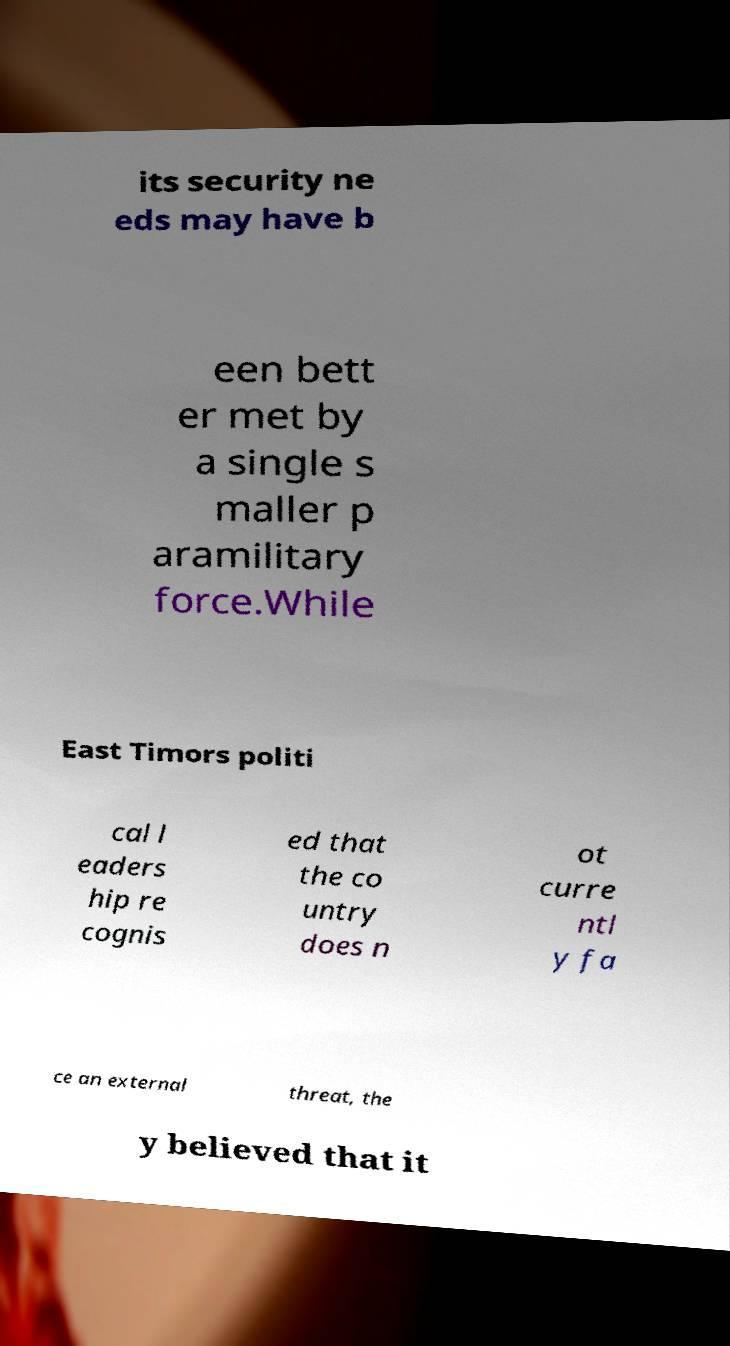Please read and relay the text visible in this image. What does it say? its security ne eds may have b een bett er met by a single s maller p aramilitary force.While East Timors politi cal l eaders hip re cognis ed that the co untry does n ot curre ntl y fa ce an external threat, the y believed that it 